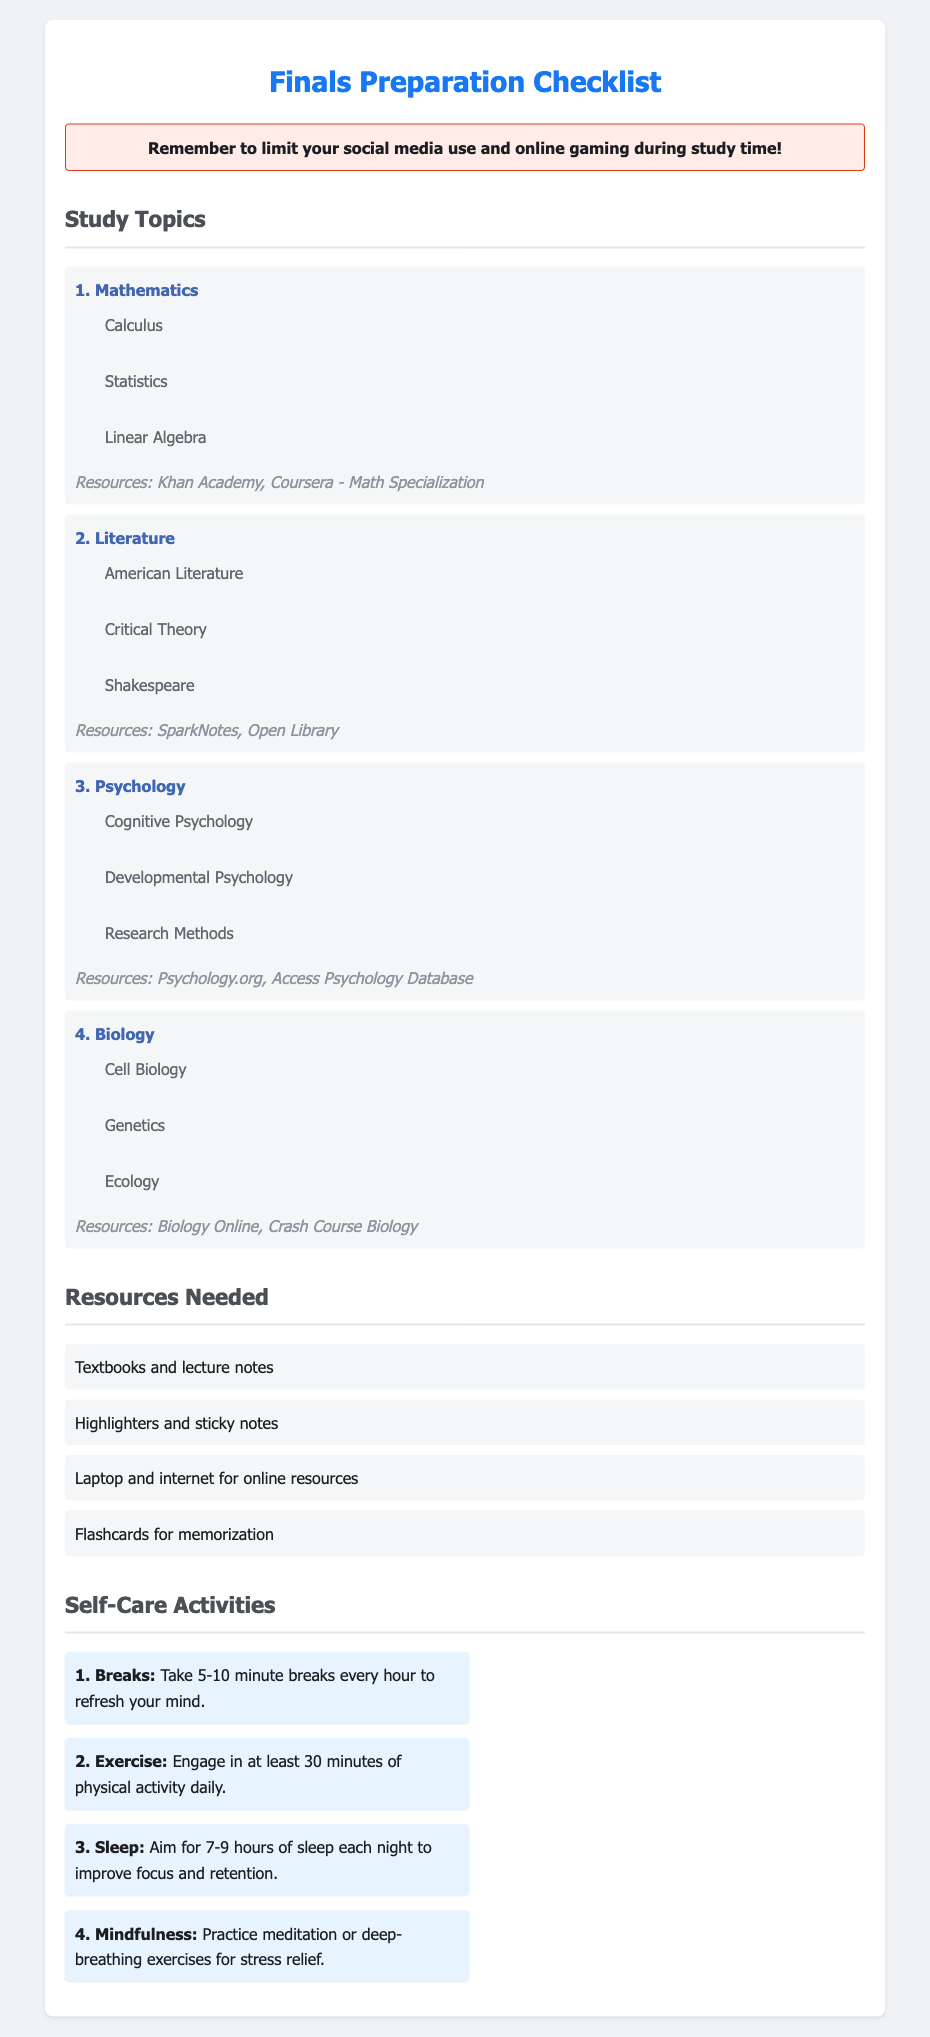What are the four main study topics listed? The document lists four main study topics: Mathematics, Literature, Psychology, and Biology.
Answer: Mathematics, Literature, Psychology, Biology How many subtopics are there under Psychology? The subtopics listed under Psychology are Cognitive Psychology, Developmental Psychology, and Research Methods, totaling three subtopics.
Answer: 3 What is one resource recommended for studying Mathematics? The document suggests Khan Academy and Coursera - Math Specialization as a resource for Mathematics study.
Answer: Khan Academy How many self-care activities are suggested in the document? The document outlines four self-care activities to engage in during finals preparation.
Answer: 4 What type of resource is recommended for memorization? The checklist mentions using flashcards as a resource for memorization.
Answer: Flashcards What is the warning message at the top of the document? The warning advises to limit social media use and online gaming during study time.
Answer: Limit your social media use and online gaming during study time! Which self-care activity involves physical activity? The document states that engaging in at least 30 minutes of physical activity daily is one of the self-care activities.
Answer: Exercise List two resources needed for finals preparation. The document states that textbooks and lecture notes, along with highlighters and sticky notes, are needed resources.
Answer: Textbooks and lecture notes; Highlighters and sticky notes Name a subtopic under Biology. The document mentions Cell Biology as a subtopic under Biology.
Answer: Cell Biology 